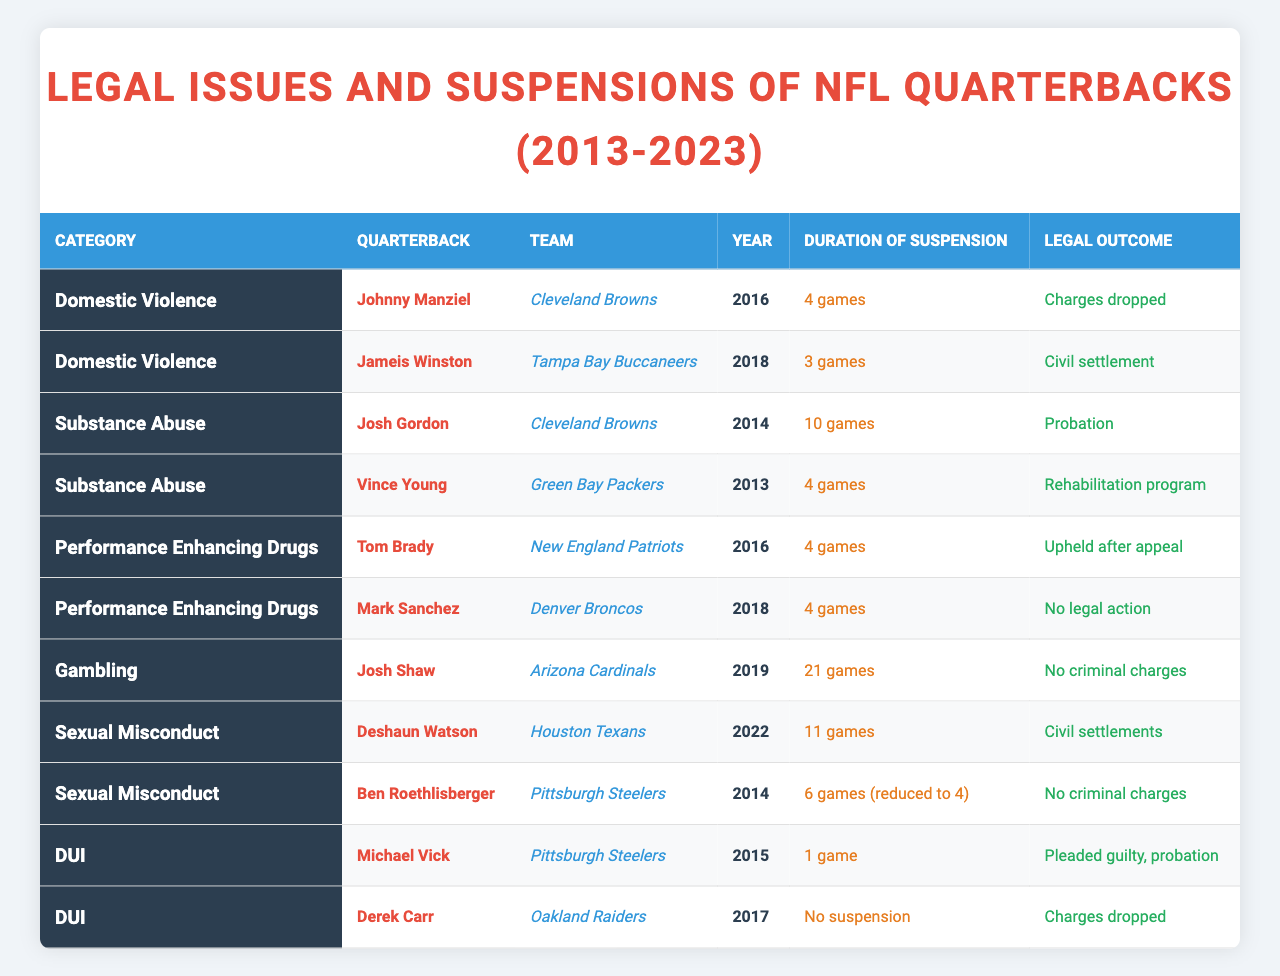What is the total number of games suspended for Johnny Manziel? Johnny Manziel was suspended for 4 games in 2016 according to the table. Thus, the total number of games suspended is simply 4.
Answer: 4 Which quarterback faced the longest suspension in the table? The longest suspension recorded in the table is 21 games for Josh Shaw in 2019. Therefore, he faced the longest suspension.
Answer: Josh Shaw How many quarterbacks faced legal issues related to Domestic Violence? In the table, there are 2 quarterbacks listed under Domestic Violence: Johnny Manziel and Jameis Winston. Therefore, the number is 2.
Answer: 2 Is there any quarterback listed that had no suspension related to DUI? The table shows that Derek Carr had no suspension related to DUI, indicating that the answer is yes.
Answer: Yes What was the average duration of suspension for quarterbacks in the Substance Abuse category? The durations of suspension for Substance Abuse are 10 and 4 games. Summing these gives 14, and averaging it over 2 quarterbacks results in 14/2 = 7 games.
Answer: 7 How many quarterbacks received civil settlements as legal outcomes? The table indicates that there are 3 quarterbacks who received civil settlements: Jameis Winston, Deshaun Watson, and Ben Roethlisberger. Summing these gives us 3.
Answer: 3 Which category had the fewest quarterbacks listed and how many were there? The Gambling category had only 1 quarterback listed (Josh Shaw), which is fewer compared to other categories. Therefore, it had the fewest.
Answer: 1 Did Tom Brady face a legal outcome that involved a criminal charge? The table shows that Tom Brady's legal outcome was "Upheld after appeal," which does not indicate any criminal charges. Therefore, the answer is no.
Answer: No What is the total number of suspensions recorded among all categories? The total number of suspensions in the table are: 4 (Manziel) + 3 (Winston) + 10 (Gordon) + 4 (Young) + 4 (Brady) + 4 (Sanchez) + 21 (Shaw) + 11 (Watson) + 6 (Roethlisberger) + 1 (Vick) = 68 games. Therefore, the total number is 68.
Answer: 68 Among the quarterbacks that faced Sexual Misconduct allegations, who had the longer suspension? In the Sexual Misconduct category, Deshaun Watson had an 11 games suspension while Ben Roethlisberger's suspension was 6 games (reduced to 4). Thus, Deshaun Watson had the longer suspension.
Answer: Deshaun Watson 